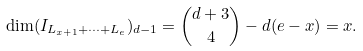Convert formula to latex. <formula><loc_0><loc_0><loc_500><loc_500>\dim ( I _ { L _ { x + 1 } + \dots + L _ { e } } ) _ { d - 1 } = { d + 3 \choose 4 } - d ( e - x ) = x .</formula> 